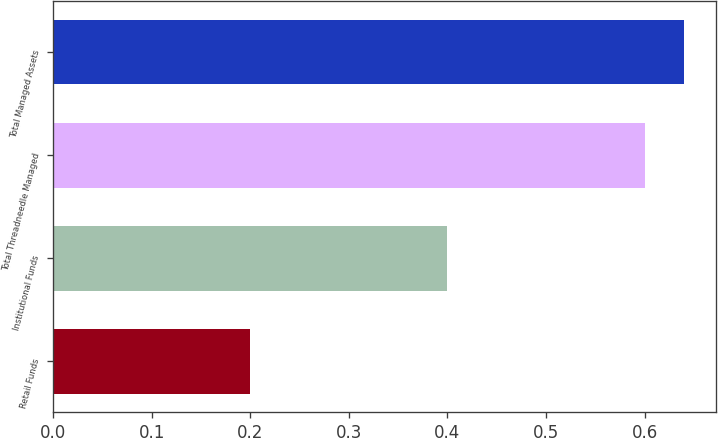<chart> <loc_0><loc_0><loc_500><loc_500><bar_chart><fcel>Retail Funds<fcel>Institutional Funds<fcel>Total Threadneedle Managed<fcel>Total Managed Assets<nl><fcel>0.2<fcel>0.4<fcel>0.6<fcel>0.64<nl></chart> 